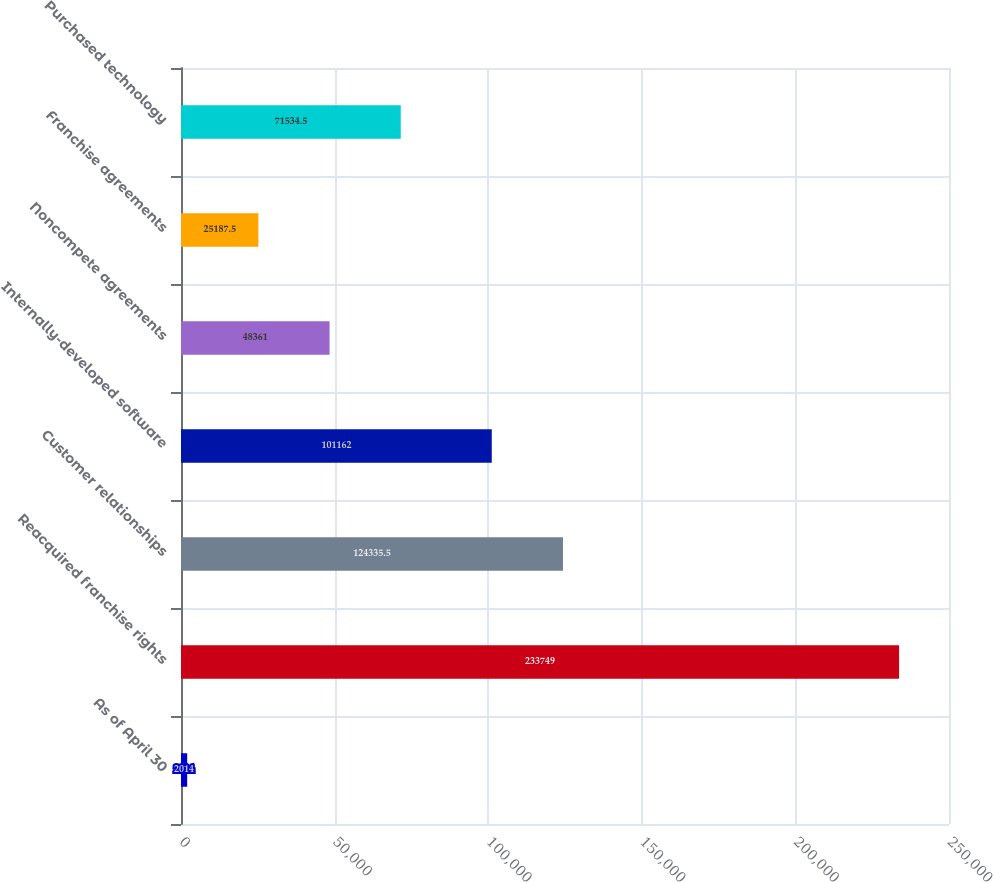<chart> <loc_0><loc_0><loc_500><loc_500><bar_chart><fcel>As of April 30<fcel>Reacquired franchise rights<fcel>Customer relationships<fcel>Internally-developed software<fcel>Noncompete agreements<fcel>Franchise agreements<fcel>Purchased technology<nl><fcel>2014<fcel>233749<fcel>124336<fcel>101162<fcel>48361<fcel>25187.5<fcel>71534.5<nl></chart> 